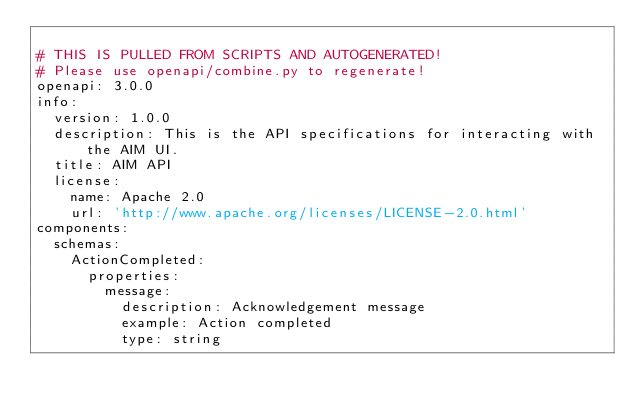<code> <loc_0><loc_0><loc_500><loc_500><_YAML_>
# THIS IS PULLED FROM SCRIPTS AND AUTOGENERATED!
# Please use openapi/combine.py to regenerate!
openapi: 3.0.0
info:
  version: 1.0.0
  description: This is the API specifications for interacting with the AIM UI.
  title: AIM API
  license:
    name: Apache 2.0
    url: 'http://www.apache.org/licenses/LICENSE-2.0.html'
components:
  schemas:
    ActionCompleted:
      properties:
        message:
          description: Acknowledgement message
          example: Action completed
          type: string</code> 